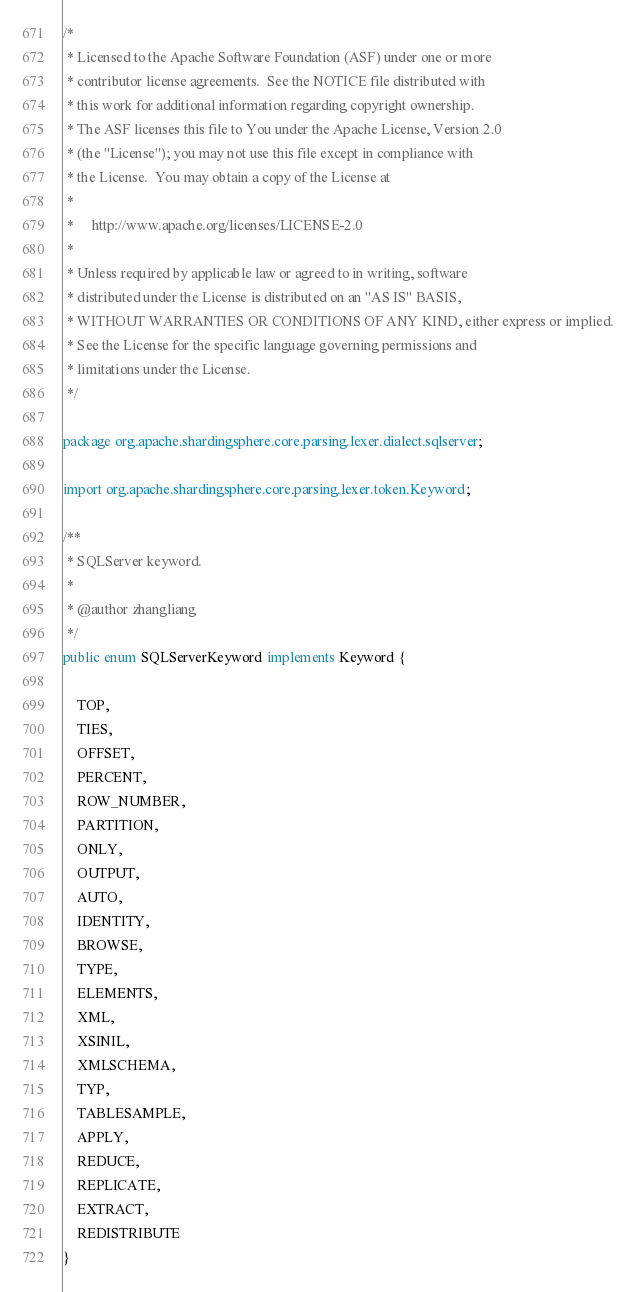<code> <loc_0><loc_0><loc_500><loc_500><_Java_>/*
 * Licensed to the Apache Software Foundation (ASF) under one or more
 * contributor license agreements.  See the NOTICE file distributed with
 * this work for additional information regarding copyright ownership.
 * The ASF licenses this file to You under the Apache License, Version 2.0
 * (the "License"); you may not use this file except in compliance with
 * the License.  You may obtain a copy of the License at
 *
 *     http://www.apache.org/licenses/LICENSE-2.0
 *
 * Unless required by applicable law or agreed to in writing, software
 * distributed under the License is distributed on an "AS IS" BASIS,
 * WITHOUT WARRANTIES OR CONDITIONS OF ANY KIND, either express or implied.
 * See the License for the specific language governing permissions and
 * limitations under the License.
 */

package org.apache.shardingsphere.core.parsing.lexer.dialect.sqlserver;

import org.apache.shardingsphere.core.parsing.lexer.token.Keyword;

/**
 * SQLServer keyword.
 * 
 * @author zhangliang 
 */
public enum SQLServerKeyword implements Keyword {
    
    TOP, 
    TIES, 
    OFFSET, 
    PERCENT,
    ROW_NUMBER,
    PARTITION, 
    ONLY, 
    OUTPUT, 
    AUTO, 
    IDENTITY, 
    BROWSE, 
    TYPE, 
    ELEMENTS, 
    XML, 
    XSINIL, 
    XMLSCHEMA, 
    TYP,
    TABLESAMPLE,
    APPLY,
    REDUCE,
    REPLICATE,
    EXTRACT,
    REDISTRIBUTE
}
</code> 